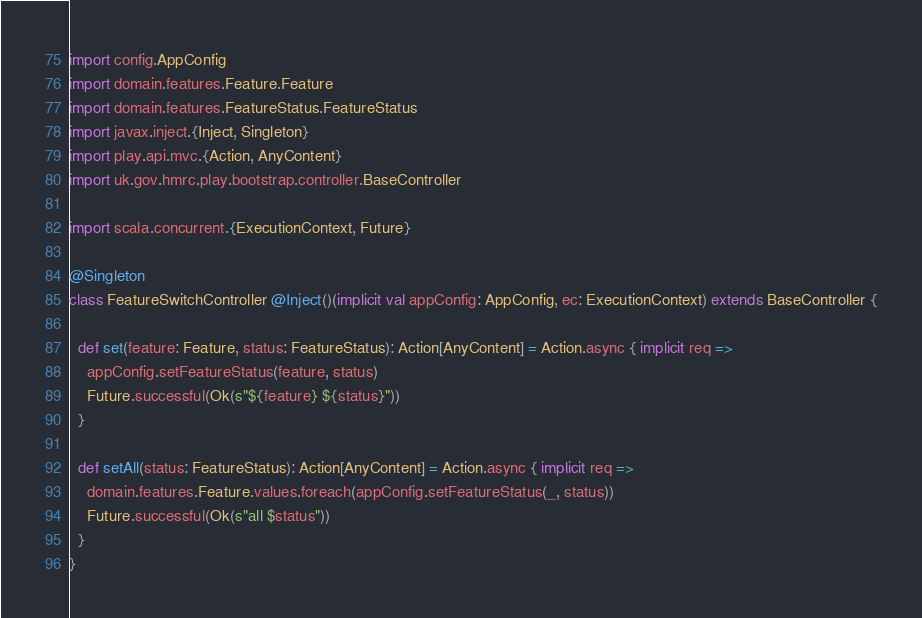<code> <loc_0><loc_0><loc_500><loc_500><_Scala_>
import config.AppConfig
import domain.features.Feature.Feature
import domain.features.FeatureStatus.FeatureStatus
import javax.inject.{Inject, Singleton}
import play.api.mvc.{Action, AnyContent}
import uk.gov.hmrc.play.bootstrap.controller.BaseController

import scala.concurrent.{ExecutionContext, Future}

@Singleton
class FeatureSwitchController @Inject()(implicit val appConfig: AppConfig, ec: ExecutionContext) extends BaseController {

  def set(feature: Feature, status: FeatureStatus): Action[AnyContent] = Action.async { implicit req =>
    appConfig.setFeatureStatus(feature, status)
    Future.successful(Ok(s"${feature} ${status}"))
  }

  def setAll(status: FeatureStatus): Action[AnyContent] = Action.async { implicit req =>
    domain.features.Feature.values.foreach(appConfig.setFeatureStatus(_, status))
    Future.successful(Ok(s"all $status"))
  }
}
</code> 